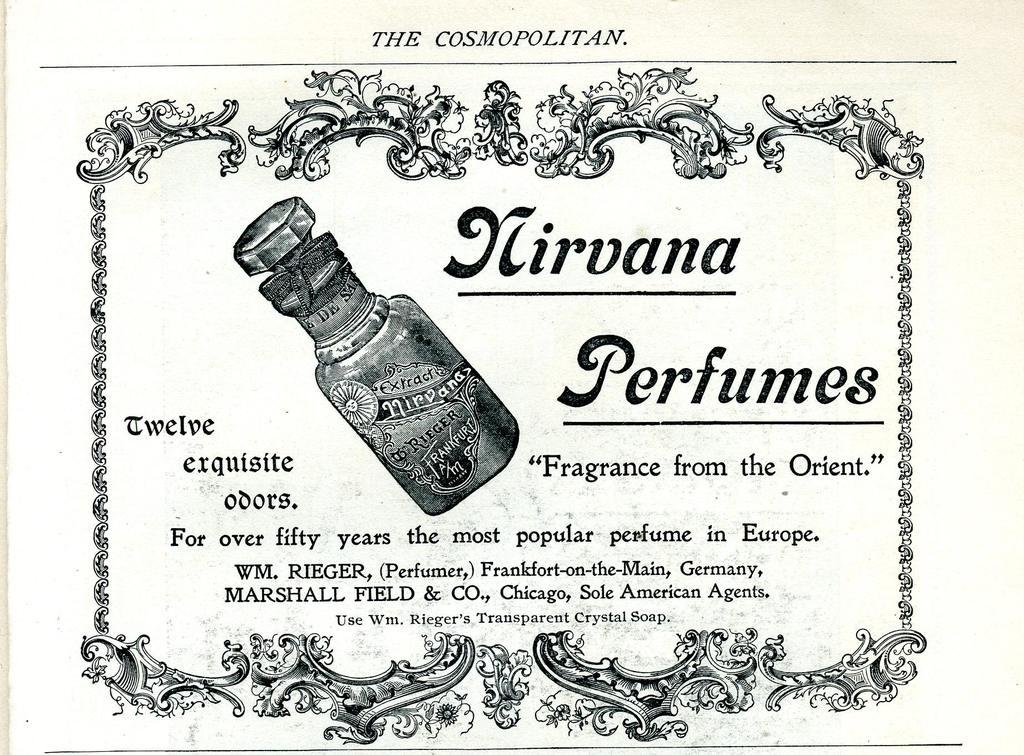<image>
Share a concise interpretation of the image provided. a paper that says 'the cosmopolitan' on the top of it 